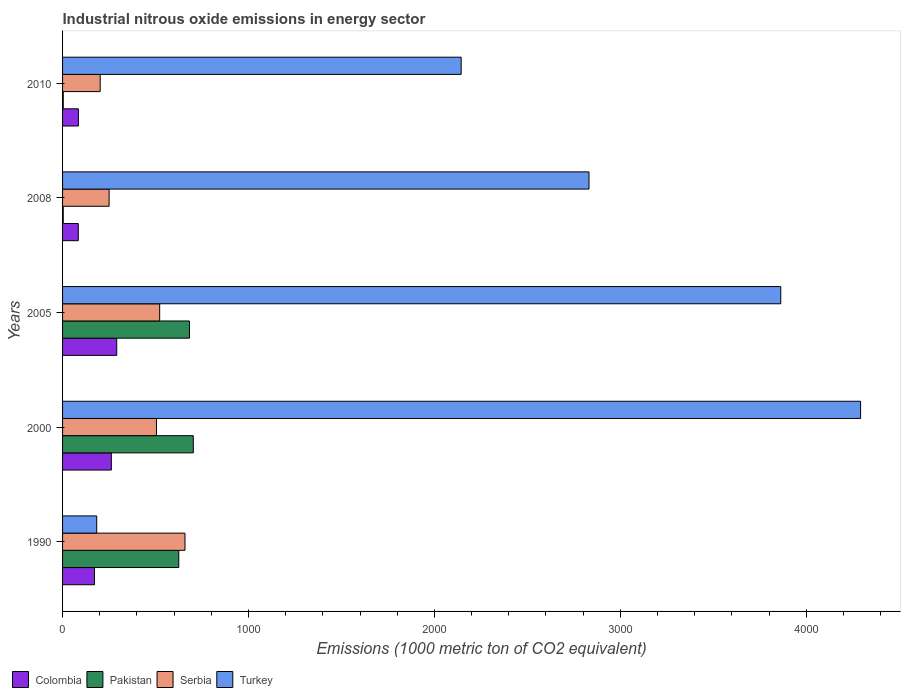How many different coloured bars are there?
Provide a short and direct response. 4. How many groups of bars are there?
Ensure brevity in your answer.  5. Are the number of bars per tick equal to the number of legend labels?
Ensure brevity in your answer.  Yes. Are the number of bars on each tick of the Y-axis equal?
Give a very brief answer. Yes. How many bars are there on the 3rd tick from the top?
Your response must be concise. 4. How many bars are there on the 1st tick from the bottom?
Provide a short and direct response. 4. What is the label of the 3rd group of bars from the top?
Provide a short and direct response. 2005. In how many cases, is the number of bars for a given year not equal to the number of legend labels?
Provide a succinct answer. 0. What is the amount of industrial nitrous oxide emitted in Serbia in 1990?
Make the answer very short. 658.4. Across all years, what is the maximum amount of industrial nitrous oxide emitted in Serbia?
Ensure brevity in your answer.  658.4. Across all years, what is the minimum amount of industrial nitrous oxide emitted in Pakistan?
Provide a short and direct response. 3.6. What is the total amount of industrial nitrous oxide emitted in Colombia in the graph?
Provide a succinct answer. 895.1. What is the difference between the amount of industrial nitrous oxide emitted in Pakistan in 2005 and that in 2010?
Keep it short and to the point. 678.7. What is the difference between the amount of industrial nitrous oxide emitted in Turkey in 2005 and the amount of industrial nitrous oxide emitted in Colombia in 2000?
Make the answer very short. 3600.4. What is the average amount of industrial nitrous oxide emitted in Turkey per year?
Ensure brevity in your answer.  2662.68. In the year 2010, what is the difference between the amount of industrial nitrous oxide emitted in Colombia and amount of industrial nitrous oxide emitted in Serbia?
Your answer should be very brief. -117.1. What is the ratio of the amount of industrial nitrous oxide emitted in Pakistan in 1990 to that in 2008?
Provide a succinct answer. 173.61. Is the difference between the amount of industrial nitrous oxide emitted in Colombia in 2000 and 2010 greater than the difference between the amount of industrial nitrous oxide emitted in Serbia in 2000 and 2010?
Your answer should be compact. No. What is the difference between the highest and the second highest amount of industrial nitrous oxide emitted in Serbia?
Provide a succinct answer. 136.1. What is the difference between the highest and the lowest amount of industrial nitrous oxide emitted in Colombia?
Your answer should be very brief. 206.6. In how many years, is the amount of industrial nitrous oxide emitted in Colombia greater than the average amount of industrial nitrous oxide emitted in Colombia taken over all years?
Your answer should be compact. 2. Is it the case that in every year, the sum of the amount of industrial nitrous oxide emitted in Colombia and amount of industrial nitrous oxide emitted in Pakistan is greater than the sum of amount of industrial nitrous oxide emitted in Serbia and amount of industrial nitrous oxide emitted in Turkey?
Your response must be concise. No. What does the 2nd bar from the top in 2010 represents?
Your answer should be very brief. Serbia. What does the 3rd bar from the bottom in 2008 represents?
Offer a terse response. Serbia. How many bars are there?
Offer a terse response. 20. Are all the bars in the graph horizontal?
Keep it short and to the point. Yes. How many legend labels are there?
Your answer should be very brief. 4. What is the title of the graph?
Ensure brevity in your answer.  Industrial nitrous oxide emissions in energy sector. Does "Macao" appear as one of the legend labels in the graph?
Offer a very short reply. No. What is the label or title of the X-axis?
Your answer should be very brief. Emissions (1000 metric ton of CO2 equivalent). What is the label or title of the Y-axis?
Your response must be concise. Years. What is the Emissions (1000 metric ton of CO2 equivalent) in Colombia in 1990?
Your response must be concise. 171.6. What is the Emissions (1000 metric ton of CO2 equivalent) in Pakistan in 1990?
Provide a succinct answer. 625. What is the Emissions (1000 metric ton of CO2 equivalent) in Serbia in 1990?
Provide a succinct answer. 658.4. What is the Emissions (1000 metric ton of CO2 equivalent) of Turkey in 1990?
Make the answer very short. 183.6. What is the Emissions (1000 metric ton of CO2 equivalent) in Colombia in 2000?
Ensure brevity in your answer.  262.3. What is the Emissions (1000 metric ton of CO2 equivalent) of Pakistan in 2000?
Give a very brief answer. 703.1. What is the Emissions (1000 metric ton of CO2 equivalent) of Serbia in 2000?
Provide a short and direct response. 505. What is the Emissions (1000 metric ton of CO2 equivalent) in Turkey in 2000?
Provide a succinct answer. 4292. What is the Emissions (1000 metric ton of CO2 equivalent) in Colombia in 2005?
Offer a very short reply. 291.3. What is the Emissions (1000 metric ton of CO2 equivalent) of Pakistan in 2005?
Offer a terse response. 682.4. What is the Emissions (1000 metric ton of CO2 equivalent) of Serbia in 2005?
Ensure brevity in your answer.  522.3. What is the Emissions (1000 metric ton of CO2 equivalent) in Turkey in 2005?
Give a very brief answer. 3862.7. What is the Emissions (1000 metric ton of CO2 equivalent) of Colombia in 2008?
Your answer should be very brief. 84.7. What is the Emissions (1000 metric ton of CO2 equivalent) in Pakistan in 2008?
Your response must be concise. 3.6. What is the Emissions (1000 metric ton of CO2 equivalent) in Serbia in 2008?
Keep it short and to the point. 250.3. What is the Emissions (1000 metric ton of CO2 equivalent) of Turkey in 2008?
Ensure brevity in your answer.  2831.3. What is the Emissions (1000 metric ton of CO2 equivalent) of Colombia in 2010?
Your answer should be very brief. 85.2. What is the Emissions (1000 metric ton of CO2 equivalent) of Pakistan in 2010?
Keep it short and to the point. 3.7. What is the Emissions (1000 metric ton of CO2 equivalent) in Serbia in 2010?
Provide a short and direct response. 202.3. What is the Emissions (1000 metric ton of CO2 equivalent) in Turkey in 2010?
Offer a terse response. 2143.8. Across all years, what is the maximum Emissions (1000 metric ton of CO2 equivalent) of Colombia?
Your answer should be very brief. 291.3. Across all years, what is the maximum Emissions (1000 metric ton of CO2 equivalent) of Pakistan?
Your answer should be very brief. 703.1. Across all years, what is the maximum Emissions (1000 metric ton of CO2 equivalent) in Serbia?
Offer a terse response. 658.4. Across all years, what is the maximum Emissions (1000 metric ton of CO2 equivalent) of Turkey?
Your answer should be compact. 4292. Across all years, what is the minimum Emissions (1000 metric ton of CO2 equivalent) in Colombia?
Offer a terse response. 84.7. Across all years, what is the minimum Emissions (1000 metric ton of CO2 equivalent) of Pakistan?
Make the answer very short. 3.6. Across all years, what is the minimum Emissions (1000 metric ton of CO2 equivalent) of Serbia?
Make the answer very short. 202.3. Across all years, what is the minimum Emissions (1000 metric ton of CO2 equivalent) in Turkey?
Offer a terse response. 183.6. What is the total Emissions (1000 metric ton of CO2 equivalent) of Colombia in the graph?
Your answer should be very brief. 895.1. What is the total Emissions (1000 metric ton of CO2 equivalent) in Pakistan in the graph?
Offer a very short reply. 2017.8. What is the total Emissions (1000 metric ton of CO2 equivalent) of Serbia in the graph?
Ensure brevity in your answer.  2138.3. What is the total Emissions (1000 metric ton of CO2 equivalent) in Turkey in the graph?
Your answer should be compact. 1.33e+04. What is the difference between the Emissions (1000 metric ton of CO2 equivalent) in Colombia in 1990 and that in 2000?
Your answer should be very brief. -90.7. What is the difference between the Emissions (1000 metric ton of CO2 equivalent) in Pakistan in 1990 and that in 2000?
Provide a succinct answer. -78.1. What is the difference between the Emissions (1000 metric ton of CO2 equivalent) of Serbia in 1990 and that in 2000?
Provide a short and direct response. 153.4. What is the difference between the Emissions (1000 metric ton of CO2 equivalent) of Turkey in 1990 and that in 2000?
Your answer should be compact. -4108.4. What is the difference between the Emissions (1000 metric ton of CO2 equivalent) of Colombia in 1990 and that in 2005?
Make the answer very short. -119.7. What is the difference between the Emissions (1000 metric ton of CO2 equivalent) in Pakistan in 1990 and that in 2005?
Your answer should be compact. -57.4. What is the difference between the Emissions (1000 metric ton of CO2 equivalent) of Serbia in 1990 and that in 2005?
Provide a short and direct response. 136.1. What is the difference between the Emissions (1000 metric ton of CO2 equivalent) in Turkey in 1990 and that in 2005?
Provide a succinct answer. -3679.1. What is the difference between the Emissions (1000 metric ton of CO2 equivalent) in Colombia in 1990 and that in 2008?
Keep it short and to the point. 86.9. What is the difference between the Emissions (1000 metric ton of CO2 equivalent) of Pakistan in 1990 and that in 2008?
Keep it short and to the point. 621.4. What is the difference between the Emissions (1000 metric ton of CO2 equivalent) in Serbia in 1990 and that in 2008?
Keep it short and to the point. 408.1. What is the difference between the Emissions (1000 metric ton of CO2 equivalent) of Turkey in 1990 and that in 2008?
Provide a short and direct response. -2647.7. What is the difference between the Emissions (1000 metric ton of CO2 equivalent) of Colombia in 1990 and that in 2010?
Offer a very short reply. 86.4. What is the difference between the Emissions (1000 metric ton of CO2 equivalent) in Pakistan in 1990 and that in 2010?
Your answer should be compact. 621.3. What is the difference between the Emissions (1000 metric ton of CO2 equivalent) in Serbia in 1990 and that in 2010?
Your response must be concise. 456.1. What is the difference between the Emissions (1000 metric ton of CO2 equivalent) of Turkey in 1990 and that in 2010?
Provide a short and direct response. -1960.2. What is the difference between the Emissions (1000 metric ton of CO2 equivalent) of Pakistan in 2000 and that in 2005?
Offer a very short reply. 20.7. What is the difference between the Emissions (1000 metric ton of CO2 equivalent) of Serbia in 2000 and that in 2005?
Your answer should be very brief. -17.3. What is the difference between the Emissions (1000 metric ton of CO2 equivalent) in Turkey in 2000 and that in 2005?
Your answer should be very brief. 429.3. What is the difference between the Emissions (1000 metric ton of CO2 equivalent) of Colombia in 2000 and that in 2008?
Provide a succinct answer. 177.6. What is the difference between the Emissions (1000 metric ton of CO2 equivalent) of Pakistan in 2000 and that in 2008?
Give a very brief answer. 699.5. What is the difference between the Emissions (1000 metric ton of CO2 equivalent) in Serbia in 2000 and that in 2008?
Your response must be concise. 254.7. What is the difference between the Emissions (1000 metric ton of CO2 equivalent) in Turkey in 2000 and that in 2008?
Offer a terse response. 1460.7. What is the difference between the Emissions (1000 metric ton of CO2 equivalent) in Colombia in 2000 and that in 2010?
Provide a short and direct response. 177.1. What is the difference between the Emissions (1000 metric ton of CO2 equivalent) in Pakistan in 2000 and that in 2010?
Your response must be concise. 699.4. What is the difference between the Emissions (1000 metric ton of CO2 equivalent) in Serbia in 2000 and that in 2010?
Offer a very short reply. 302.7. What is the difference between the Emissions (1000 metric ton of CO2 equivalent) of Turkey in 2000 and that in 2010?
Keep it short and to the point. 2148.2. What is the difference between the Emissions (1000 metric ton of CO2 equivalent) of Colombia in 2005 and that in 2008?
Offer a very short reply. 206.6. What is the difference between the Emissions (1000 metric ton of CO2 equivalent) of Pakistan in 2005 and that in 2008?
Offer a terse response. 678.8. What is the difference between the Emissions (1000 metric ton of CO2 equivalent) of Serbia in 2005 and that in 2008?
Give a very brief answer. 272. What is the difference between the Emissions (1000 metric ton of CO2 equivalent) in Turkey in 2005 and that in 2008?
Your answer should be very brief. 1031.4. What is the difference between the Emissions (1000 metric ton of CO2 equivalent) of Colombia in 2005 and that in 2010?
Your answer should be very brief. 206.1. What is the difference between the Emissions (1000 metric ton of CO2 equivalent) in Pakistan in 2005 and that in 2010?
Make the answer very short. 678.7. What is the difference between the Emissions (1000 metric ton of CO2 equivalent) of Serbia in 2005 and that in 2010?
Give a very brief answer. 320. What is the difference between the Emissions (1000 metric ton of CO2 equivalent) in Turkey in 2005 and that in 2010?
Offer a very short reply. 1718.9. What is the difference between the Emissions (1000 metric ton of CO2 equivalent) of Colombia in 2008 and that in 2010?
Ensure brevity in your answer.  -0.5. What is the difference between the Emissions (1000 metric ton of CO2 equivalent) in Turkey in 2008 and that in 2010?
Give a very brief answer. 687.5. What is the difference between the Emissions (1000 metric ton of CO2 equivalent) of Colombia in 1990 and the Emissions (1000 metric ton of CO2 equivalent) of Pakistan in 2000?
Provide a succinct answer. -531.5. What is the difference between the Emissions (1000 metric ton of CO2 equivalent) in Colombia in 1990 and the Emissions (1000 metric ton of CO2 equivalent) in Serbia in 2000?
Offer a very short reply. -333.4. What is the difference between the Emissions (1000 metric ton of CO2 equivalent) in Colombia in 1990 and the Emissions (1000 metric ton of CO2 equivalent) in Turkey in 2000?
Your answer should be very brief. -4120.4. What is the difference between the Emissions (1000 metric ton of CO2 equivalent) of Pakistan in 1990 and the Emissions (1000 metric ton of CO2 equivalent) of Serbia in 2000?
Ensure brevity in your answer.  120. What is the difference between the Emissions (1000 metric ton of CO2 equivalent) in Pakistan in 1990 and the Emissions (1000 metric ton of CO2 equivalent) in Turkey in 2000?
Provide a short and direct response. -3667. What is the difference between the Emissions (1000 metric ton of CO2 equivalent) in Serbia in 1990 and the Emissions (1000 metric ton of CO2 equivalent) in Turkey in 2000?
Offer a terse response. -3633.6. What is the difference between the Emissions (1000 metric ton of CO2 equivalent) in Colombia in 1990 and the Emissions (1000 metric ton of CO2 equivalent) in Pakistan in 2005?
Offer a very short reply. -510.8. What is the difference between the Emissions (1000 metric ton of CO2 equivalent) in Colombia in 1990 and the Emissions (1000 metric ton of CO2 equivalent) in Serbia in 2005?
Your answer should be very brief. -350.7. What is the difference between the Emissions (1000 metric ton of CO2 equivalent) in Colombia in 1990 and the Emissions (1000 metric ton of CO2 equivalent) in Turkey in 2005?
Offer a terse response. -3691.1. What is the difference between the Emissions (1000 metric ton of CO2 equivalent) of Pakistan in 1990 and the Emissions (1000 metric ton of CO2 equivalent) of Serbia in 2005?
Provide a short and direct response. 102.7. What is the difference between the Emissions (1000 metric ton of CO2 equivalent) in Pakistan in 1990 and the Emissions (1000 metric ton of CO2 equivalent) in Turkey in 2005?
Provide a succinct answer. -3237.7. What is the difference between the Emissions (1000 metric ton of CO2 equivalent) of Serbia in 1990 and the Emissions (1000 metric ton of CO2 equivalent) of Turkey in 2005?
Your response must be concise. -3204.3. What is the difference between the Emissions (1000 metric ton of CO2 equivalent) in Colombia in 1990 and the Emissions (1000 metric ton of CO2 equivalent) in Pakistan in 2008?
Offer a very short reply. 168. What is the difference between the Emissions (1000 metric ton of CO2 equivalent) of Colombia in 1990 and the Emissions (1000 metric ton of CO2 equivalent) of Serbia in 2008?
Give a very brief answer. -78.7. What is the difference between the Emissions (1000 metric ton of CO2 equivalent) in Colombia in 1990 and the Emissions (1000 metric ton of CO2 equivalent) in Turkey in 2008?
Make the answer very short. -2659.7. What is the difference between the Emissions (1000 metric ton of CO2 equivalent) in Pakistan in 1990 and the Emissions (1000 metric ton of CO2 equivalent) in Serbia in 2008?
Offer a very short reply. 374.7. What is the difference between the Emissions (1000 metric ton of CO2 equivalent) of Pakistan in 1990 and the Emissions (1000 metric ton of CO2 equivalent) of Turkey in 2008?
Your response must be concise. -2206.3. What is the difference between the Emissions (1000 metric ton of CO2 equivalent) of Serbia in 1990 and the Emissions (1000 metric ton of CO2 equivalent) of Turkey in 2008?
Your answer should be very brief. -2172.9. What is the difference between the Emissions (1000 metric ton of CO2 equivalent) of Colombia in 1990 and the Emissions (1000 metric ton of CO2 equivalent) of Pakistan in 2010?
Keep it short and to the point. 167.9. What is the difference between the Emissions (1000 metric ton of CO2 equivalent) in Colombia in 1990 and the Emissions (1000 metric ton of CO2 equivalent) in Serbia in 2010?
Keep it short and to the point. -30.7. What is the difference between the Emissions (1000 metric ton of CO2 equivalent) in Colombia in 1990 and the Emissions (1000 metric ton of CO2 equivalent) in Turkey in 2010?
Keep it short and to the point. -1972.2. What is the difference between the Emissions (1000 metric ton of CO2 equivalent) in Pakistan in 1990 and the Emissions (1000 metric ton of CO2 equivalent) in Serbia in 2010?
Provide a succinct answer. 422.7. What is the difference between the Emissions (1000 metric ton of CO2 equivalent) in Pakistan in 1990 and the Emissions (1000 metric ton of CO2 equivalent) in Turkey in 2010?
Give a very brief answer. -1518.8. What is the difference between the Emissions (1000 metric ton of CO2 equivalent) of Serbia in 1990 and the Emissions (1000 metric ton of CO2 equivalent) of Turkey in 2010?
Provide a succinct answer. -1485.4. What is the difference between the Emissions (1000 metric ton of CO2 equivalent) of Colombia in 2000 and the Emissions (1000 metric ton of CO2 equivalent) of Pakistan in 2005?
Offer a very short reply. -420.1. What is the difference between the Emissions (1000 metric ton of CO2 equivalent) in Colombia in 2000 and the Emissions (1000 metric ton of CO2 equivalent) in Serbia in 2005?
Your answer should be very brief. -260. What is the difference between the Emissions (1000 metric ton of CO2 equivalent) in Colombia in 2000 and the Emissions (1000 metric ton of CO2 equivalent) in Turkey in 2005?
Give a very brief answer. -3600.4. What is the difference between the Emissions (1000 metric ton of CO2 equivalent) in Pakistan in 2000 and the Emissions (1000 metric ton of CO2 equivalent) in Serbia in 2005?
Your answer should be very brief. 180.8. What is the difference between the Emissions (1000 metric ton of CO2 equivalent) of Pakistan in 2000 and the Emissions (1000 metric ton of CO2 equivalent) of Turkey in 2005?
Your response must be concise. -3159.6. What is the difference between the Emissions (1000 metric ton of CO2 equivalent) of Serbia in 2000 and the Emissions (1000 metric ton of CO2 equivalent) of Turkey in 2005?
Ensure brevity in your answer.  -3357.7. What is the difference between the Emissions (1000 metric ton of CO2 equivalent) of Colombia in 2000 and the Emissions (1000 metric ton of CO2 equivalent) of Pakistan in 2008?
Keep it short and to the point. 258.7. What is the difference between the Emissions (1000 metric ton of CO2 equivalent) of Colombia in 2000 and the Emissions (1000 metric ton of CO2 equivalent) of Serbia in 2008?
Make the answer very short. 12. What is the difference between the Emissions (1000 metric ton of CO2 equivalent) of Colombia in 2000 and the Emissions (1000 metric ton of CO2 equivalent) of Turkey in 2008?
Give a very brief answer. -2569. What is the difference between the Emissions (1000 metric ton of CO2 equivalent) in Pakistan in 2000 and the Emissions (1000 metric ton of CO2 equivalent) in Serbia in 2008?
Provide a short and direct response. 452.8. What is the difference between the Emissions (1000 metric ton of CO2 equivalent) in Pakistan in 2000 and the Emissions (1000 metric ton of CO2 equivalent) in Turkey in 2008?
Provide a short and direct response. -2128.2. What is the difference between the Emissions (1000 metric ton of CO2 equivalent) of Serbia in 2000 and the Emissions (1000 metric ton of CO2 equivalent) of Turkey in 2008?
Your answer should be very brief. -2326.3. What is the difference between the Emissions (1000 metric ton of CO2 equivalent) in Colombia in 2000 and the Emissions (1000 metric ton of CO2 equivalent) in Pakistan in 2010?
Ensure brevity in your answer.  258.6. What is the difference between the Emissions (1000 metric ton of CO2 equivalent) in Colombia in 2000 and the Emissions (1000 metric ton of CO2 equivalent) in Turkey in 2010?
Make the answer very short. -1881.5. What is the difference between the Emissions (1000 metric ton of CO2 equivalent) in Pakistan in 2000 and the Emissions (1000 metric ton of CO2 equivalent) in Serbia in 2010?
Give a very brief answer. 500.8. What is the difference between the Emissions (1000 metric ton of CO2 equivalent) of Pakistan in 2000 and the Emissions (1000 metric ton of CO2 equivalent) of Turkey in 2010?
Give a very brief answer. -1440.7. What is the difference between the Emissions (1000 metric ton of CO2 equivalent) of Serbia in 2000 and the Emissions (1000 metric ton of CO2 equivalent) of Turkey in 2010?
Your answer should be compact. -1638.8. What is the difference between the Emissions (1000 metric ton of CO2 equivalent) of Colombia in 2005 and the Emissions (1000 metric ton of CO2 equivalent) of Pakistan in 2008?
Offer a very short reply. 287.7. What is the difference between the Emissions (1000 metric ton of CO2 equivalent) in Colombia in 2005 and the Emissions (1000 metric ton of CO2 equivalent) in Turkey in 2008?
Your response must be concise. -2540. What is the difference between the Emissions (1000 metric ton of CO2 equivalent) in Pakistan in 2005 and the Emissions (1000 metric ton of CO2 equivalent) in Serbia in 2008?
Your answer should be compact. 432.1. What is the difference between the Emissions (1000 metric ton of CO2 equivalent) of Pakistan in 2005 and the Emissions (1000 metric ton of CO2 equivalent) of Turkey in 2008?
Offer a very short reply. -2148.9. What is the difference between the Emissions (1000 metric ton of CO2 equivalent) in Serbia in 2005 and the Emissions (1000 metric ton of CO2 equivalent) in Turkey in 2008?
Keep it short and to the point. -2309. What is the difference between the Emissions (1000 metric ton of CO2 equivalent) of Colombia in 2005 and the Emissions (1000 metric ton of CO2 equivalent) of Pakistan in 2010?
Make the answer very short. 287.6. What is the difference between the Emissions (1000 metric ton of CO2 equivalent) in Colombia in 2005 and the Emissions (1000 metric ton of CO2 equivalent) in Serbia in 2010?
Make the answer very short. 89. What is the difference between the Emissions (1000 metric ton of CO2 equivalent) of Colombia in 2005 and the Emissions (1000 metric ton of CO2 equivalent) of Turkey in 2010?
Provide a succinct answer. -1852.5. What is the difference between the Emissions (1000 metric ton of CO2 equivalent) of Pakistan in 2005 and the Emissions (1000 metric ton of CO2 equivalent) of Serbia in 2010?
Keep it short and to the point. 480.1. What is the difference between the Emissions (1000 metric ton of CO2 equivalent) in Pakistan in 2005 and the Emissions (1000 metric ton of CO2 equivalent) in Turkey in 2010?
Keep it short and to the point. -1461.4. What is the difference between the Emissions (1000 metric ton of CO2 equivalent) in Serbia in 2005 and the Emissions (1000 metric ton of CO2 equivalent) in Turkey in 2010?
Your answer should be very brief. -1621.5. What is the difference between the Emissions (1000 metric ton of CO2 equivalent) of Colombia in 2008 and the Emissions (1000 metric ton of CO2 equivalent) of Pakistan in 2010?
Your response must be concise. 81. What is the difference between the Emissions (1000 metric ton of CO2 equivalent) in Colombia in 2008 and the Emissions (1000 metric ton of CO2 equivalent) in Serbia in 2010?
Keep it short and to the point. -117.6. What is the difference between the Emissions (1000 metric ton of CO2 equivalent) in Colombia in 2008 and the Emissions (1000 metric ton of CO2 equivalent) in Turkey in 2010?
Give a very brief answer. -2059.1. What is the difference between the Emissions (1000 metric ton of CO2 equivalent) in Pakistan in 2008 and the Emissions (1000 metric ton of CO2 equivalent) in Serbia in 2010?
Provide a short and direct response. -198.7. What is the difference between the Emissions (1000 metric ton of CO2 equivalent) in Pakistan in 2008 and the Emissions (1000 metric ton of CO2 equivalent) in Turkey in 2010?
Keep it short and to the point. -2140.2. What is the difference between the Emissions (1000 metric ton of CO2 equivalent) of Serbia in 2008 and the Emissions (1000 metric ton of CO2 equivalent) of Turkey in 2010?
Your answer should be very brief. -1893.5. What is the average Emissions (1000 metric ton of CO2 equivalent) in Colombia per year?
Give a very brief answer. 179.02. What is the average Emissions (1000 metric ton of CO2 equivalent) of Pakistan per year?
Ensure brevity in your answer.  403.56. What is the average Emissions (1000 metric ton of CO2 equivalent) in Serbia per year?
Your answer should be very brief. 427.66. What is the average Emissions (1000 metric ton of CO2 equivalent) in Turkey per year?
Ensure brevity in your answer.  2662.68. In the year 1990, what is the difference between the Emissions (1000 metric ton of CO2 equivalent) of Colombia and Emissions (1000 metric ton of CO2 equivalent) of Pakistan?
Keep it short and to the point. -453.4. In the year 1990, what is the difference between the Emissions (1000 metric ton of CO2 equivalent) in Colombia and Emissions (1000 metric ton of CO2 equivalent) in Serbia?
Your answer should be compact. -486.8. In the year 1990, what is the difference between the Emissions (1000 metric ton of CO2 equivalent) in Colombia and Emissions (1000 metric ton of CO2 equivalent) in Turkey?
Your response must be concise. -12. In the year 1990, what is the difference between the Emissions (1000 metric ton of CO2 equivalent) in Pakistan and Emissions (1000 metric ton of CO2 equivalent) in Serbia?
Offer a very short reply. -33.4. In the year 1990, what is the difference between the Emissions (1000 metric ton of CO2 equivalent) of Pakistan and Emissions (1000 metric ton of CO2 equivalent) of Turkey?
Offer a very short reply. 441.4. In the year 1990, what is the difference between the Emissions (1000 metric ton of CO2 equivalent) in Serbia and Emissions (1000 metric ton of CO2 equivalent) in Turkey?
Your response must be concise. 474.8. In the year 2000, what is the difference between the Emissions (1000 metric ton of CO2 equivalent) in Colombia and Emissions (1000 metric ton of CO2 equivalent) in Pakistan?
Your answer should be very brief. -440.8. In the year 2000, what is the difference between the Emissions (1000 metric ton of CO2 equivalent) in Colombia and Emissions (1000 metric ton of CO2 equivalent) in Serbia?
Provide a short and direct response. -242.7. In the year 2000, what is the difference between the Emissions (1000 metric ton of CO2 equivalent) in Colombia and Emissions (1000 metric ton of CO2 equivalent) in Turkey?
Offer a very short reply. -4029.7. In the year 2000, what is the difference between the Emissions (1000 metric ton of CO2 equivalent) in Pakistan and Emissions (1000 metric ton of CO2 equivalent) in Serbia?
Make the answer very short. 198.1. In the year 2000, what is the difference between the Emissions (1000 metric ton of CO2 equivalent) of Pakistan and Emissions (1000 metric ton of CO2 equivalent) of Turkey?
Your answer should be compact. -3588.9. In the year 2000, what is the difference between the Emissions (1000 metric ton of CO2 equivalent) in Serbia and Emissions (1000 metric ton of CO2 equivalent) in Turkey?
Give a very brief answer. -3787. In the year 2005, what is the difference between the Emissions (1000 metric ton of CO2 equivalent) of Colombia and Emissions (1000 metric ton of CO2 equivalent) of Pakistan?
Make the answer very short. -391.1. In the year 2005, what is the difference between the Emissions (1000 metric ton of CO2 equivalent) of Colombia and Emissions (1000 metric ton of CO2 equivalent) of Serbia?
Your answer should be very brief. -231. In the year 2005, what is the difference between the Emissions (1000 metric ton of CO2 equivalent) of Colombia and Emissions (1000 metric ton of CO2 equivalent) of Turkey?
Provide a succinct answer. -3571.4. In the year 2005, what is the difference between the Emissions (1000 metric ton of CO2 equivalent) of Pakistan and Emissions (1000 metric ton of CO2 equivalent) of Serbia?
Provide a succinct answer. 160.1. In the year 2005, what is the difference between the Emissions (1000 metric ton of CO2 equivalent) of Pakistan and Emissions (1000 metric ton of CO2 equivalent) of Turkey?
Provide a short and direct response. -3180.3. In the year 2005, what is the difference between the Emissions (1000 metric ton of CO2 equivalent) of Serbia and Emissions (1000 metric ton of CO2 equivalent) of Turkey?
Offer a very short reply. -3340.4. In the year 2008, what is the difference between the Emissions (1000 metric ton of CO2 equivalent) of Colombia and Emissions (1000 metric ton of CO2 equivalent) of Pakistan?
Offer a very short reply. 81.1. In the year 2008, what is the difference between the Emissions (1000 metric ton of CO2 equivalent) of Colombia and Emissions (1000 metric ton of CO2 equivalent) of Serbia?
Offer a terse response. -165.6. In the year 2008, what is the difference between the Emissions (1000 metric ton of CO2 equivalent) in Colombia and Emissions (1000 metric ton of CO2 equivalent) in Turkey?
Offer a very short reply. -2746.6. In the year 2008, what is the difference between the Emissions (1000 metric ton of CO2 equivalent) in Pakistan and Emissions (1000 metric ton of CO2 equivalent) in Serbia?
Offer a very short reply. -246.7. In the year 2008, what is the difference between the Emissions (1000 metric ton of CO2 equivalent) in Pakistan and Emissions (1000 metric ton of CO2 equivalent) in Turkey?
Provide a succinct answer. -2827.7. In the year 2008, what is the difference between the Emissions (1000 metric ton of CO2 equivalent) in Serbia and Emissions (1000 metric ton of CO2 equivalent) in Turkey?
Ensure brevity in your answer.  -2581. In the year 2010, what is the difference between the Emissions (1000 metric ton of CO2 equivalent) of Colombia and Emissions (1000 metric ton of CO2 equivalent) of Pakistan?
Your answer should be very brief. 81.5. In the year 2010, what is the difference between the Emissions (1000 metric ton of CO2 equivalent) of Colombia and Emissions (1000 metric ton of CO2 equivalent) of Serbia?
Offer a terse response. -117.1. In the year 2010, what is the difference between the Emissions (1000 metric ton of CO2 equivalent) in Colombia and Emissions (1000 metric ton of CO2 equivalent) in Turkey?
Your response must be concise. -2058.6. In the year 2010, what is the difference between the Emissions (1000 metric ton of CO2 equivalent) in Pakistan and Emissions (1000 metric ton of CO2 equivalent) in Serbia?
Your answer should be very brief. -198.6. In the year 2010, what is the difference between the Emissions (1000 metric ton of CO2 equivalent) in Pakistan and Emissions (1000 metric ton of CO2 equivalent) in Turkey?
Make the answer very short. -2140.1. In the year 2010, what is the difference between the Emissions (1000 metric ton of CO2 equivalent) in Serbia and Emissions (1000 metric ton of CO2 equivalent) in Turkey?
Offer a terse response. -1941.5. What is the ratio of the Emissions (1000 metric ton of CO2 equivalent) in Colombia in 1990 to that in 2000?
Provide a succinct answer. 0.65. What is the ratio of the Emissions (1000 metric ton of CO2 equivalent) of Pakistan in 1990 to that in 2000?
Provide a succinct answer. 0.89. What is the ratio of the Emissions (1000 metric ton of CO2 equivalent) of Serbia in 1990 to that in 2000?
Offer a terse response. 1.3. What is the ratio of the Emissions (1000 metric ton of CO2 equivalent) in Turkey in 1990 to that in 2000?
Offer a terse response. 0.04. What is the ratio of the Emissions (1000 metric ton of CO2 equivalent) of Colombia in 1990 to that in 2005?
Provide a succinct answer. 0.59. What is the ratio of the Emissions (1000 metric ton of CO2 equivalent) of Pakistan in 1990 to that in 2005?
Offer a terse response. 0.92. What is the ratio of the Emissions (1000 metric ton of CO2 equivalent) of Serbia in 1990 to that in 2005?
Give a very brief answer. 1.26. What is the ratio of the Emissions (1000 metric ton of CO2 equivalent) in Turkey in 1990 to that in 2005?
Make the answer very short. 0.05. What is the ratio of the Emissions (1000 metric ton of CO2 equivalent) in Colombia in 1990 to that in 2008?
Give a very brief answer. 2.03. What is the ratio of the Emissions (1000 metric ton of CO2 equivalent) in Pakistan in 1990 to that in 2008?
Offer a terse response. 173.61. What is the ratio of the Emissions (1000 metric ton of CO2 equivalent) in Serbia in 1990 to that in 2008?
Provide a succinct answer. 2.63. What is the ratio of the Emissions (1000 metric ton of CO2 equivalent) in Turkey in 1990 to that in 2008?
Your answer should be very brief. 0.06. What is the ratio of the Emissions (1000 metric ton of CO2 equivalent) in Colombia in 1990 to that in 2010?
Your answer should be compact. 2.01. What is the ratio of the Emissions (1000 metric ton of CO2 equivalent) of Pakistan in 1990 to that in 2010?
Provide a succinct answer. 168.92. What is the ratio of the Emissions (1000 metric ton of CO2 equivalent) in Serbia in 1990 to that in 2010?
Offer a terse response. 3.25. What is the ratio of the Emissions (1000 metric ton of CO2 equivalent) in Turkey in 1990 to that in 2010?
Offer a terse response. 0.09. What is the ratio of the Emissions (1000 metric ton of CO2 equivalent) in Colombia in 2000 to that in 2005?
Your answer should be very brief. 0.9. What is the ratio of the Emissions (1000 metric ton of CO2 equivalent) of Pakistan in 2000 to that in 2005?
Provide a succinct answer. 1.03. What is the ratio of the Emissions (1000 metric ton of CO2 equivalent) in Serbia in 2000 to that in 2005?
Keep it short and to the point. 0.97. What is the ratio of the Emissions (1000 metric ton of CO2 equivalent) in Colombia in 2000 to that in 2008?
Ensure brevity in your answer.  3.1. What is the ratio of the Emissions (1000 metric ton of CO2 equivalent) in Pakistan in 2000 to that in 2008?
Give a very brief answer. 195.31. What is the ratio of the Emissions (1000 metric ton of CO2 equivalent) of Serbia in 2000 to that in 2008?
Keep it short and to the point. 2.02. What is the ratio of the Emissions (1000 metric ton of CO2 equivalent) in Turkey in 2000 to that in 2008?
Give a very brief answer. 1.52. What is the ratio of the Emissions (1000 metric ton of CO2 equivalent) in Colombia in 2000 to that in 2010?
Offer a terse response. 3.08. What is the ratio of the Emissions (1000 metric ton of CO2 equivalent) of Pakistan in 2000 to that in 2010?
Your answer should be very brief. 190.03. What is the ratio of the Emissions (1000 metric ton of CO2 equivalent) in Serbia in 2000 to that in 2010?
Your answer should be very brief. 2.5. What is the ratio of the Emissions (1000 metric ton of CO2 equivalent) of Turkey in 2000 to that in 2010?
Offer a terse response. 2. What is the ratio of the Emissions (1000 metric ton of CO2 equivalent) of Colombia in 2005 to that in 2008?
Provide a succinct answer. 3.44. What is the ratio of the Emissions (1000 metric ton of CO2 equivalent) in Pakistan in 2005 to that in 2008?
Offer a terse response. 189.56. What is the ratio of the Emissions (1000 metric ton of CO2 equivalent) of Serbia in 2005 to that in 2008?
Give a very brief answer. 2.09. What is the ratio of the Emissions (1000 metric ton of CO2 equivalent) in Turkey in 2005 to that in 2008?
Make the answer very short. 1.36. What is the ratio of the Emissions (1000 metric ton of CO2 equivalent) of Colombia in 2005 to that in 2010?
Ensure brevity in your answer.  3.42. What is the ratio of the Emissions (1000 metric ton of CO2 equivalent) in Pakistan in 2005 to that in 2010?
Your answer should be compact. 184.43. What is the ratio of the Emissions (1000 metric ton of CO2 equivalent) in Serbia in 2005 to that in 2010?
Provide a succinct answer. 2.58. What is the ratio of the Emissions (1000 metric ton of CO2 equivalent) of Turkey in 2005 to that in 2010?
Your answer should be very brief. 1.8. What is the ratio of the Emissions (1000 metric ton of CO2 equivalent) in Colombia in 2008 to that in 2010?
Offer a very short reply. 0.99. What is the ratio of the Emissions (1000 metric ton of CO2 equivalent) in Pakistan in 2008 to that in 2010?
Provide a short and direct response. 0.97. What is the ratio of the Emissions (1000 metric ton of CO2 equivalent) in Serbia in 2008 to that in 2010?
Provide a short and direct response. 1.24. What is the ratio of the Emissions (1000 metric ton of CO2 equivalent) in Turkey in 2008 to that in 2010?
Your answer should be very brief. 1.32. What is the difference between the highest and the second highest Emissions (1000 metric ton of CO2 equivalent) of Pakistan?
Give a very brief answer. 20.7. What is the difference between the highest and the second highest Emissions (1000 metric ton of CO2 equivalent) of Serbia?
Keep it short and to the point. 136.1. What is the difference between the highest and the second highest Emissions (1000 metric ton of CO2 equivalent) of Turkey?
Give a very brief answer. 429.3. What is the difference between the highest and the lowest Emissions (1000 metric ton of CO2 equivalent) of Colombia?
Provide a succinct answer. 206.6. What is the difference between the highest and the lowest Emissions (1000 metric ton of CO2 equivalent) of Pakistan?
Keep it short and to the point. 699.5. What is the difference between the highest and the lowest Emissions (1000 metric ton of CO2 equivalent) of Serbia?
Ensure brevity in your answer.  456.1. What is the difference between the highest and the lowest Emissions (1000 metric ton of CO2 equivalent) of Turkey?
Keep it short and to the point. 4108.4. 